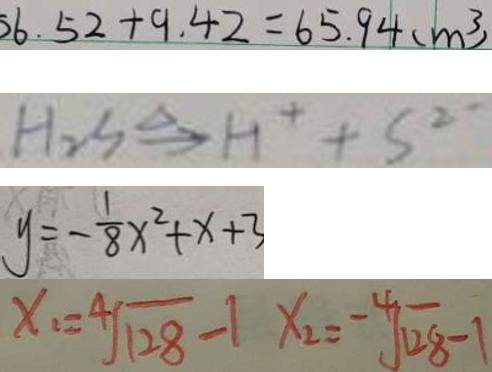Convert formula to latex. <formula><loc_0><loc_0><loc_500><loc_500>6 . 5 2 + 9 . 4 2 = 6 5 . 9 4 ( m ^ { 3 } ) 
 H _ { 2 } S \xrightarrow { \Delta } H ^ { + } + S ^ { 2 - } 
 y = - \frac { 1 } { 8 } x ^ { 2 } + x + 3 
 x _ { 1 } = \sqrt [ 4 ] { 1 2 8 } - 1 x _ { 2 } = \sqrt [ - 4 ] { 1 2 8 } - 1</formula> 